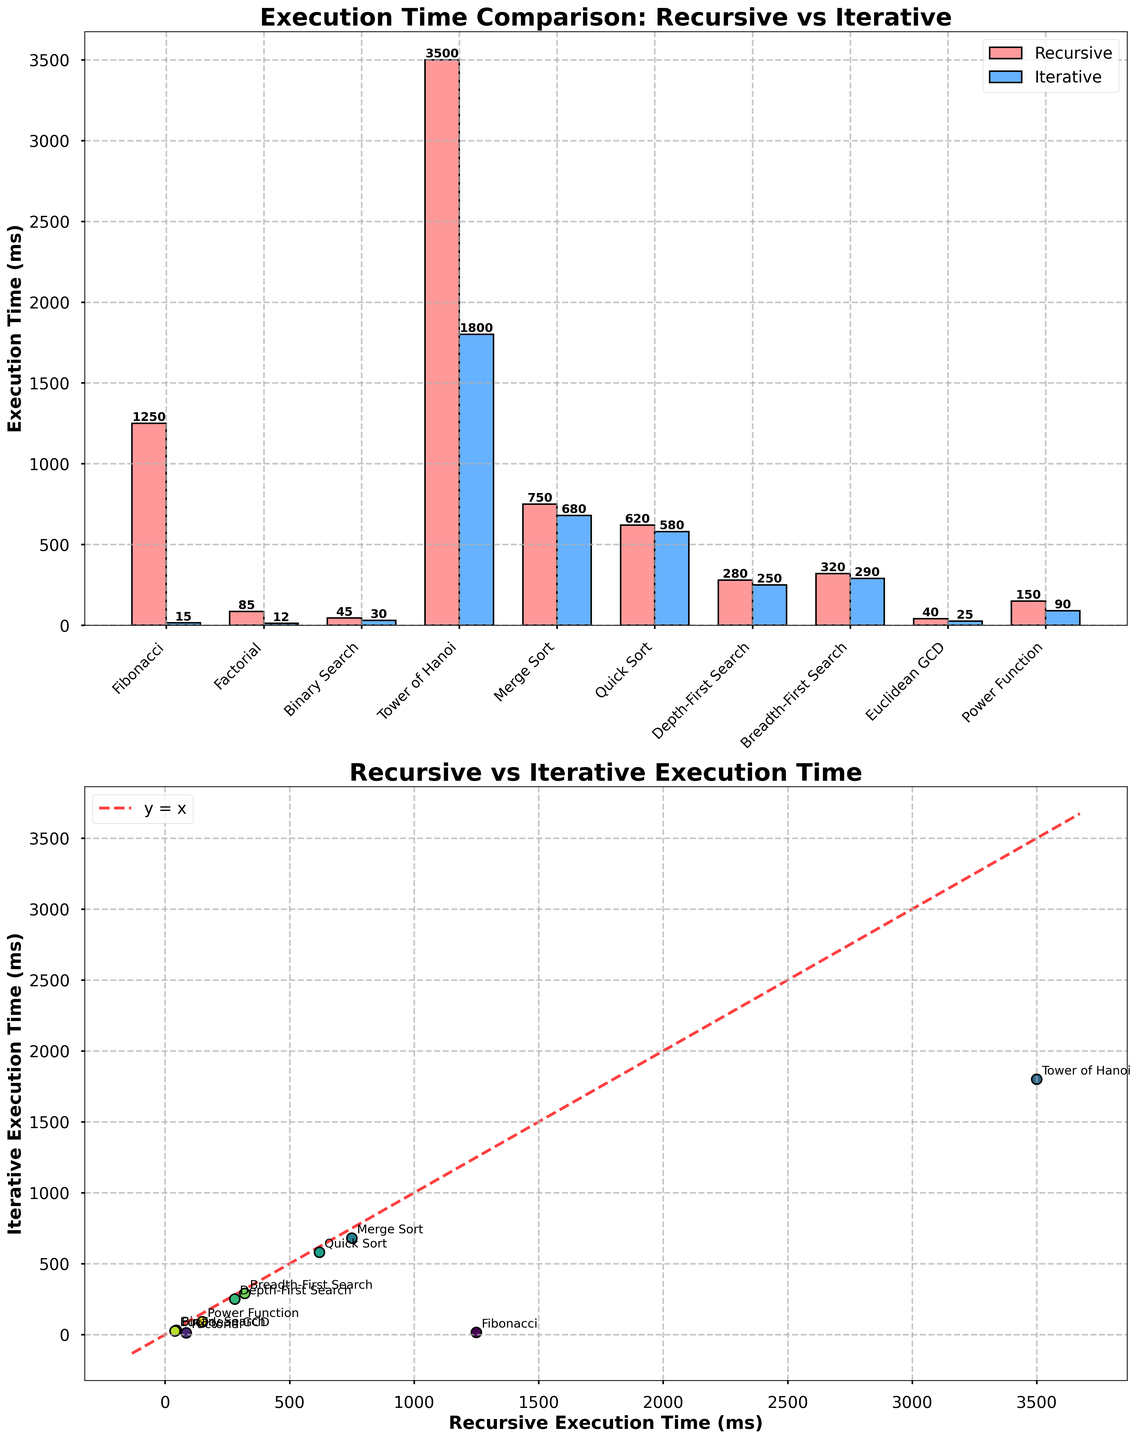What is the title of the bar plot? The titles are displayed at the top of each subplot. For the bar plot, it's clearly written as "Execution Time Comparison: Recursive vs Iterative".
Answer: Execution Time Comparison: Recursive vs Iterative What are the execution times for Fibonacci for both recursive and iterative approaches? Look for the bars labeled "Fibonacci". The heights of the bars and the text inside them show the values. The recursive approach has an execution time of 1250 ms, and the iterative approach has an execution time of 15 ms.
Answer: 1250 ms (recursive), 15 ms (iterative) Which algorithm has the largest difference in execution time between the recursive and iterative approaches? By scanning the length of the bars or values in the bar plot, "Tower of Hanoi" stands out with recursive taking 3500 ms and iterative taking 1800 ms, resulting in the largest difference of 1700 ms.
Answer: Tower of Hanoi What is the overall trend between recursive and iterative execution times in the scatter plot? The scatter plot compares recursive and iterative times directly. Most points are above the y=x line, meaning recursive times are generally greater than iterative times.
Answer: Recursive times generally greater What does the red dashed line in the scatter plot represent? The red dashed line in the scatter plot is labeled "y = x", representing the line where recursive and iterative execution times would be equal. Points above this line indicate longer recursive times, and below indicate longer iterative times.
Answer: Line y = x For which algorithm is the execution time nearly equal between recursive and iterative approaches? Examine the scatter plot for points close to the red dashed line. The "Merge Sort" (recursive = 750 ms, iterative = 680 ms) scatter point is near this line.
Answer: Merge Sort What is the average execution time for the recursive approach across all algorithms? Sum all the recursive times and divide by the total number of algorithms. (1250 + 85 + 45 + 3500 + 750 + 620 + 280 + 320 + 40 + 150) / 10 = 7040 / 10 = 704 ms on average.
Answer: 704 ms Which algorithm has the shortest execution time in the iterative approach? Check the iterative bars in the bar plot or points in the scatter plot for the smallest value. The "Fibonacci" iterative time is 15 ms, the shortest.
Answer: Fibonacci How much faster is the iterative approach compared to the recursive approach for the "Euclidean GCD" algorithm? Find Euclidean GCD and calculate the difference: Recursive (40 ms) - Iterative (25 ms) = 15 ms faster.
Answer: 15 ms faster Are there any algorithms where the iterative approach takes more time than the recursive? Scan both plots. All iterative times are either equal to or less than their recursive counterparts. No iterative time is greater.
Answer: No algorithms 